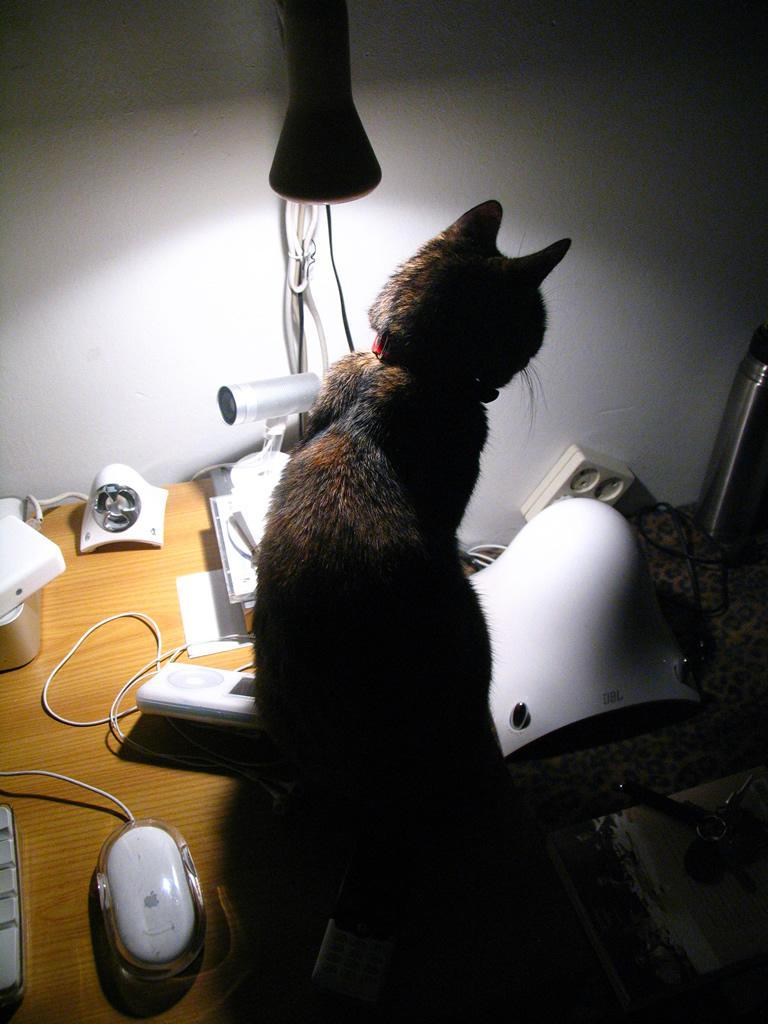What type of table is in the image? There is a wooden table in the image. What animals are present on the table? A mouse and a cat are present on the table. What object can be seen on the table that is related to electricity? There is a wire on the table. What is the background of the image? There is a wall in the background of the image. What is attached to the wall? There are wires on the wall. What is the source of light in the image? There is a lamp with light in the image. What type of food is being prepared on the trail in the image? There is no trail or food preparation visible in the image. 